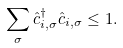Convert formula to latex. <formula><loc_0><loc_0><loc_500><loc_500>\sum _ { \sigma } \hat { c } _ { i , \sigma } ^ { \dagger } \hat { c } _ { i , \sigma } \leq 1 .</formula> 